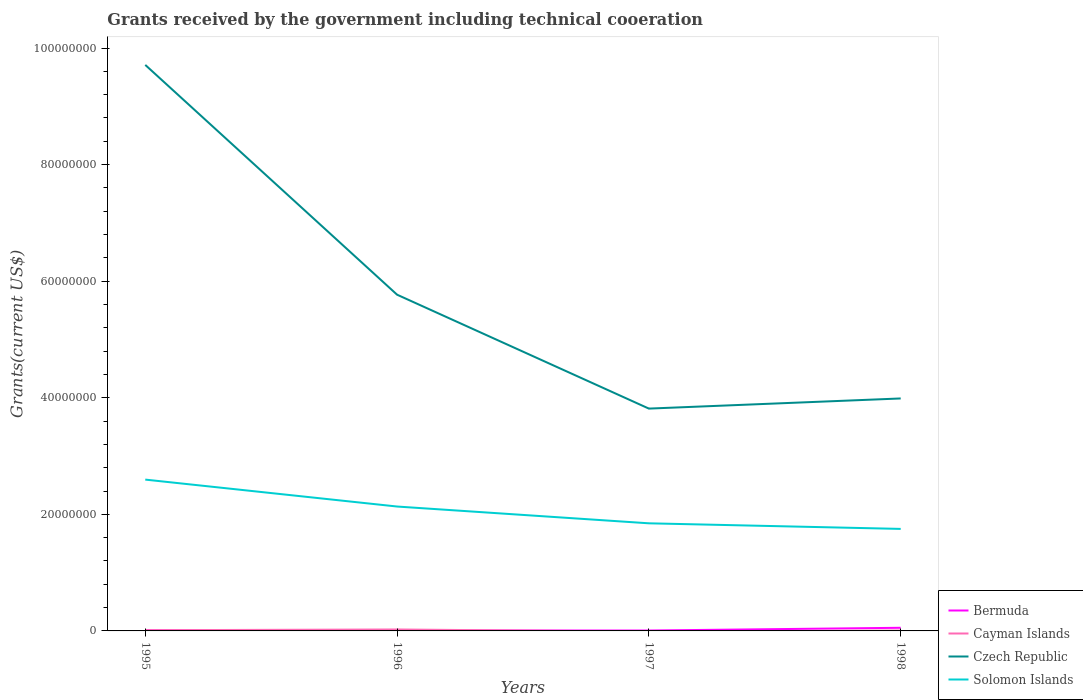How many different coloured lines are there?
Keep it short and to the point. 4. Does the line corresponding to Solomon Islands intersect with the line corresponding to Czech Republic?
Provide a short and direct response. No. Is the number of lines equal to the number of legend labels?
Offer a terse response. No. What is the total total grants received by the government in Czech Republic in the graph?
Offer a terse response. 5.90e+07. What is the difference between the highest and the lowest total grants received by the government in Cayman Islands?
Make the answer very short. 2. Is the total grants received by the government in Bermuda strictly greater than the total grants received by the government in Czech Republic over the years?
Keep it short and to the point. Yes. How many lines are there?
Provide a short and direct response. 4. What is the difference between two consecutive major ticks on the Y-axis?
Provide a succinct answer. 2.00e+07. Are the values on the major ticks of Y-axis written in scientific E-notation?
Your answer should be compact. No. Does the graph contain any zero values?
Provide a short and direct response. Yes. Does the graph contain grids?
Your answer should be very brief. No. Where does the legend appear in the graph?
Your answer should be very brief. Bottom right. How are the legend labels stacked?
Your response must be concise. Vertical. What is the title of the graph?
Your response must be concise. Grants received by the government including technical cooeration. Does "Palau" appear as one of the legend labels in the graph?
Ensure brevity in your answer.  No. What is the label or title of the Y-axis?
Give a very brief answer. Grants(current US$). What is the Grants(current US$) in Cayman Islands in 1995?
Your answer should be compact. 1.20e+05. What is the Grants(current US$) in Czech Republic in 1995?
Your response must be concise. 9.71e+07. What is the Grants(current US$) of Solomon Islands in 1995?
Your response must be concise. 2.60e+07. What is the Grants(current US$) in Bermuda in 1996?
Offer a very short reply. 7.00e+04. What is the Grants(current US$) of Czech Republic in 1996?
Make the answer very short. 5.77e+07. What is the Grants(current US$) of Solomon Islands in 1996?
Make the answer very short. 2.13e+07. What is the Grants(current US$) of Bermuda in 1997?
Give a very brief answer. 7.00e+04. What is the Grants(current US$) in Cayman Islands in 1997?
Provide a short and direct response. 0. What is the Grants(current US$) of Czech Republic in 1997?
Keep it short and to the point. 3.81e+07. What is the Grants(current US$) in Solomon Islands in 1997?
Provide a succinct answer. 1.85e+07. What is the Grants(current US$) of Bermuda in 1998?
Your answer should be very brief. 5.40e+05. What is the Grants(current US$) of Czech Republic in 1998?
Your answer should be compact. 3.99e+07. What is the Grants(current US$) of Solomon Islands in 1998?
Provide a short and direct response. 1.75e+07. Across all years, what is the maximum Grants(current US$) in Bermuda?
Give a very brief answer. 5.40e+05. Across all years, what is the maximum Grants(current US$) of Cayman Islands?
Your response must be concise. 2.50e+05. Across all years, what is the maximum Grants(current US$) of Czech Republic?
Offer a terse response. 9.71e+07. Across all years, what is the maximum Grants(current US$) of Solomon Islands?
Ensure brevity in your answer.  2.60e+07. Across all years, what is the minimum Grants(current US$) of Bermuda?
Make the answer very short. 7.00e+04. Across all years, what is the minimum Grants(current US$) of Czech Republic?
Provide a succinct answer. 3.81e+07. Across all years, what is the minimum Grants(current US$) in Solomon Islands?
Provide a short and direct response. 1.75e+07. What is the total Grants(current US$) in Bermuda in the graph?
Give a very brief answer. 7.90e+05. What is the total Grants(current US$) of Czech Republic in the graph?
Ensure brevity in your answer.  2.33e+08. What is the total Grants(current US$) of Solomon Islands in the graph?
Give a very brief answer. 8.33e+07. What is the difference between the Grants(current US$) of Bermuda in 1995 and that in 1996?
Give a very brief answer. 4.00e+04. What is the difference between the Grants(current US$) of Czech Republic in 1995 and that in 1996?
Your response must be concise. 3.94e+07. What is the difference between the Grants(current US$) of Solomon Islands in 1995 and that in 1996?
Ensure brevity in your answer.  4.62e+06. What is the difference between the Grants(current US$) in Czech Republic in 1995 and that in 1997?
Your answer should be very brief. 5.90e+07. What is the difference between the Grants(current US$) of Solomon Islands in 1995 and that in 1997?
Keep it short and to the point. 7.50e+06. What is the difference between the Grants(current US$) of Bermuda in 1995 and that in 1998?
Ensure brevity in your answer.  -4.30e+05. What is the difference between the Grants(current US$) of Czech Republic in 1995 and that in 1998?
Ensure brevity in your answer.  5.72e+07. What is the difference between the Grants(current US$) in Solomon Islands in 1995 and that in 1998?
Offer a terse response. 8.46e+06. What is the difference between the Grants(current US$) of Czech Republic in 1996 and that in 1997?
Your answer should be compact. 1.95e+07. What is the difference between the Grants(current US$) of Solomon Islands in 1996 and that in 1997?
Your response must be concise. 2.88e+06. What is the difference between the Grants(current US$) of Bermuda in 1996 and that in 1998?
Provide a short and direct response. -4.70e+05. What is the difference between the Grants(current US$) of Cayman Islands in 1996 and that in 1998?
Give a very brief answer. 1.80e+05. What is the difference between the Grants(current US$) in Czech Republic in 1996 and that in 1998?
Make the answer very short. 1.78e+07. What is the difference between the Grants(current US$) of Solomon Islands in 1996 and that in 1998?
Offer a very short reply. 3.84e+06. What is the difference between the Grants(current US$) of Bermuda in 1997 and that in 1998?
Your answer should be compact. -4.70e+05. What is the difference between the Grants(current US$) of Czech Republic in 1997 and that in 1998?
Give a very brief answer. -1.74e+06. What is the difference between the Grants(current US$) in Solomon Islands in 1997 and that in 1998?
Offer a terse response. 9.60e+05. What is the difference between the Grants(current US$) in Bermuda in 1995 and the Grants(current US$) in Cayman Islands in 1996?
Offer a very short reply. -1.40e+05. What is the difference between the Grants(current US$) of Bermuda in 1995 and the Grants(current US$) of Czech Republic in 1996?
Your response must be concise. -5.76e+07. What is the difference between the Grants(current US$) in Bermuda in 1995 and the Grants(current US$) in Solomon Islands in 1996?
Your response must be concise. -2.12e+07. What is the difference between the Grants(current US$) of Cayman Islands in 1995 and the Grants(current US$) of Czech Republic in 1996?
Your answer should be very brief. -5.76e+07. What is the difference between the Grants(current US$) of Cayman Islands in 1995 and the Grants(current US$) of Solomon Islands in 1996?
Offer a very short reply. -2.12e+07. What is the difference between the Grants(current US$) of Czech Republic in 1995 and the Grants(current US$) of Solomon Islands in 1996?
Offer a terse response. 7.58e+07. What is the difference between the Grants(current US$) in Bermuda in 1995 and the Grants(current US$) in Czech Republic in 1997?
Make the answer very short. -3.80e+07. What is the difference between the Grants(current US$) in Bermuda in 1995 and the Grants(current US$) in Solomon Islands in 1997?
Provide a succinct answer. -1.84e+07. What is the difference between the Grants(current US$) of Cayman Islands in 1995 and the Grants(current US$) of Czech Republic in 1997?
Your answer should be compact. -3.80e+07. What is the difference between the Grants(current US$) in Cayman Islands in 1995 and the Grants(current US$) in Solomon Islands in 1997?
Offer a terse response. -1.83e+07. What is the difference between the Grants(current US$) of Czech Republic in 1995 and the Grants(current US$) of Solomon Islands in 1997?
Your answer should be very brief. 7.86e+07. What is the difference between the Grants(current US$) of Bermuda in 1995 and the Grants(current US$) of Czech Republic in 1998?
Offer a terse response. -3.98e+07. What is the difference between the Grants(current US$) of Bermuda in 1995 and the Grants(current US$) of Solomon Islands in 1998?
Your response must be concise. -1.74e+07. What is the difference between the Grants(current US$) in Cayman Islands in 1995 and the Grants(current US$) in Czech Republic in 1998?
Provide a succinct answer. -3.98e+07. What is the difference between the Grants(current US$) in Cayman Islands in 1995 and the Grants(current US$) in Solomon Islands in 1998?
Your answer should be very brief. -1.74e+07. What is the difference between the Grants(current US$) in Czech Republic in 1995 and the Grants(current US$) in Solomon Islands in 1998?
Your response must be concise. 7.96e+07. What is the difference between the Grants(current US$) of Bermuda in 1996 and the Grants(current US$) of Czech Republic in 1997?
Your response must be concise. -3.81e+07. What is the difference between the Grants(current US$) of Bermuda in 1996 and the Grants(current US$) of Solomon Islands in 1997?
Your answer should be compact. -1.84e+07. What is the difference between the Grants(current US$) in Cayman Islands in 1996 and the Grants(current US$) in Czech Republic in 1997?
Ensure brevity in your answer.  -3.79e+07. What is the difference between the Grants(current US$) in Cayman Islands in 1996 and the Grants(current US$) in Solomon Islands in 1997?
Provide a short and direct response. -1.82e+07. What is the difference between the Grants(current US$) of Czech Republic in 1996 and the Grants(current US$) of Solomon Islands in 1997?
Provide a short and direct response. 3.92e+07. What is the difference between the Grants(current US$) of Bermuda in 1996 and the Grants(current US$) of Cayman Islands in 1998?
Make the answer very short. 0. What is the difference between the Grants(current US$) of Bermuda in 1996 and the Grants(current US$) of Czech Republic in 1998?
Ensure brevity in your answer.  -3.98e+07. What is the difference between the Grants(current US$) in Bermuda in 1996 and the Grants(current US$) in Solomon Islands in 1998?
Ensure brevity in your answer.  -1.74e+07. What is the difference between the Grants(current US$) in Cayman Islands in 1996 and the Grants(current US$) in Czech Republic in 1998?
Offer a terse response. -3.96e+07. What is the difference between the Grants(current US$) of Cayman Islands in 1996 and the Grants(current US$) of Solomon Islands in 1998?
Make the answer very short. -1.72e+07. What is the difference between the Grants(current US$) in Czech Republic in 1996 and the Grants(current US$) in Solomon Islands in 1998?
Ensure brevity in your answer.  4.02e+07. What is the difference between the Grants(current US$) of Bermuda in 1997 and the Grants(current US$) of Cayman Islands in 1998?
Ensure brevity in your answer.  0. What is the difference between the Grants(current US$) of Bermuda in 1997 and the Grants(current US$) of Czech Republic in 1998?
Ensure brevity in your answer.  -3.98e+07. What is the difference between the Grants(current US$) in Bermuda in 1997 and the Grants(current US$) in Solomon Islands in 1998?
Offer a very short reply. -1.74e+07. What is the difference between the Grants(current US$) of Czech Republic in 1997 and the Grants(current US$) of Solomon Islands in 1998?
Make the answer very short. 2.06e+07. What is the average Grants(current US$) in Bermuda per year?
Provide a short and direct response. 1.98e+05. What is the average Grants(current US$) in Cayman Islands per year?
Make the answer very short. 1.10e+05. What is the average Grants(current US$) in Czech Republic per year?
Your answer should be very brief. 5.82e+07. What is the average Grants(current US$) in Solomon Islands per year?
Provide a succinct answer. 2.08e+07. In the year 1995, what is the difference between the Grants(current US$) in Bermuda and Grants(current US$) in Czech Republic?
Provide a succinct answer. -9.70e+07. In the year 1995, what is the difference between the Grants(current US$) in Bermuda and Grants(current US$) in Solomon Islands?
Give a very brief answer. -2.58e+07. In the year 1995, what is the difference between the Grants(current US$) of Cayman Islands and Grants(current US$) of Czech Republic?
Provide a short and direct response. -9.70e+07. In the year 1995, what is the difference between the Grants(current US$) of Cayman Islands and Grants(current US$) of Solomon Islands?
Keep it short and to the point. -2.58e+07. In the year 1995, what is the difference between the Grants(current US$) of Czech Republic and Grants(current US$) of Solomon Islands?
Provide a short and direct response. 7.11e+07. In the year 1996, what is the difference between the Grants(current US$) in Bermuda and Grants(current US$) in Cayman Islands?
Your answer should be compact. -1.80e+05. In the year 1996, what is the difference between the Grants(current US$) in Bermuda and Grants(current US$) in Czech Republic?
Provide a short and direct response. -5.76e+07. In the year 1996, what is the difference between the Grants(current US$) in Bermuda and Grants(current US$) in Solomon Islands?
Make the answer very short. -2.13e+07. In the year 1996, what is the difference between the Grants(current US$) in Cayman Islands and Grants(current US$) in Czech Republic?
Give a very brief answer. -5.74e+07. In the year 1996, what is the difference between the Grants(current US$) in Cayman Islands and Grants(current US$) in Solomon Islands?
Offer a very short reply. -2.11e+07. In the year 1996, what is the difference between the Grants(current US$) of Czech Republic and Grants(current US$) of Solomon Islands?
Your answer should be very brief. 3.63e+07. In the year 1997, what is the difference between the Grants(current US$) in Bermuda and Grants(current US$) in Czech Republic?
Offer a terse response. -3.81e+07. In the year 1997, what is the difference between the Grants(current US$) of Bermuda and Grants(current US$) of Solomon Islands?
Your answer should be very brief. -1.84e+07. In the year 1997, what is the difference between the Grants(current US$) in Czech Republic and Grants(current US$) in Solomon Islands?
Your answer should be very brief. 1.97e+07. In the year 1998, what is the difference between the Grants(current US$) of Bermuda and Grants(current US$) of Czech Republic?
Offer a terse response. -3.93e+07. In the year 1998, what is the difference between the Grants(current US$) of Bermuda and Grants(current US$) of Solomon Islands?
Give a very brief answer. -1.70e+07. In the year 1998, what is the difference between the Grants(current US$) of Cayman Islands and Grants(current US$) of Czech Republic?
Your answer should be very brief. -3.98e+07. In the year 1998, what is the difference between the Grants(current US$) in Cayman Islands and Grants(current US$) in Solomon Islands?
Your answer should be very brief. -1.74e+07. In the year 1998, what is the difference between the Grants(current US$) of Czech Republic and Grants(current US$) of Solomon Islands?
Offer a terse response. 2.24e+07. What is the ratio of the Grants(current US$) in Bermuda in 1995 to that in 1996?
Offer a terse response. 1.57. What is the ratio of the Grants(current US$) of Cayman Islands in 1995 to that in 1996?
Your answer should be compact. 0.48. What is the ratio of the Grants(current US$) of Czech Republic in 1995 to that in 1996?
Provide a short and direct response. 1.68. What is the ratio of the Grants(current US$) of Solomon Islands in 1995 to that in 1996?
Give a very brief answer. 1.22. What is the ratio of the Grants(current US$) of Bermuda in 1995 to that in 1997?
Provide a short and direct response. 1.57. What is the ratio of the Grants(current US$) in Czech Republic in 1995 to that in 1997?
Provide a succinct answer. 2.55. What is the ratio of the Grants(current US$) in Solomon Islands in 1995 to that in 1997?
Your response must be concise. 1.41. What is the ratio of the Grants(current US$) in Bermuda in 1995 to that in 1998?
Provide a short and direct response. 0.2. What is the ratio of the Grants(current US$) in Cayman Islands in 1995 to that in 1998?
Offer a terse response. 1.71. What is the ratio of the Grants(current US$) of Czech Republic in 1995 to that in 1998?
Your answer should be very brief. 2.43. What is the ratio of the Grants(current US$) of Solomon Islands in 1995 to that in 1998?
Offer a very short reply. 1.48. What is the ratio of the Grants(current US$) in Czech Republic in 1996 to that in 1997?
Give a very brief answer. 1.51. What is the ratio of the Grants(current US$) in Solomon Islands in 1996 to that in 1997?
Provide a short and direct response. 1.16. What is the ratio of the Grants(current US$) of Bermuda in 1996 to that in 1998?
Your answer should be compact. 0.13. What is the ratio of the Grants(current US$) of Cayman Islands in 1996 to that in 1998?
Make the answer very short. 3.57. What is the ratio of the Grants(current US$) of Czech Republic in 1996 to that in 1998?
Ensure brevity in your answer.  1.45. What is the ratio of the Grants(current US$) in Solomon Islands in 1996 to that in 1998?
Your response must be concise. 1.22. What is the ratio of the Grants(current US$) of Bermuda in 1997 to that in 1998?
Your answer should be compact. 0.13. What is the ratio of the Grants(current US$) in Czech Republic in 1997 to that in 1998?
Your response must be concise. 0.96. What is the ratio of the Grants(current US$) in Solomon Islands in 1997 to that in 1998?
Provide a succinct answer. 1.05. What is the difference between the highest and the second highest Grants(current US$) of Bermuda?
Your response must be concise. 4.30e+05. What is the difference between the highest and the second highest Grants(current US$) of Czech Republic?
Your answer should be very brief. 3.94e+07. What is the difference between the highest and the second highest Grants(current US$) in Solomon Islands?
Your response must be concise. 4.62e+06. What is the difference between the highest and the lowest Grants(current US$) of Bermuda?
Give a very brief answer. 4.70e+05. What is the difference between the highest and the lowest Grants(current US$) in Cayman Islands?
Your response must be concise. 2.50e+05. What is the difference between the highest and the lowest Grants(current US$) of Czech Republic?
Keep it short and to the point. 5.90e+07. What is the difference between the highest and the lowest Grants(current US$) in Solomon Islands?
Your response must be concise. 8.46e+06. 